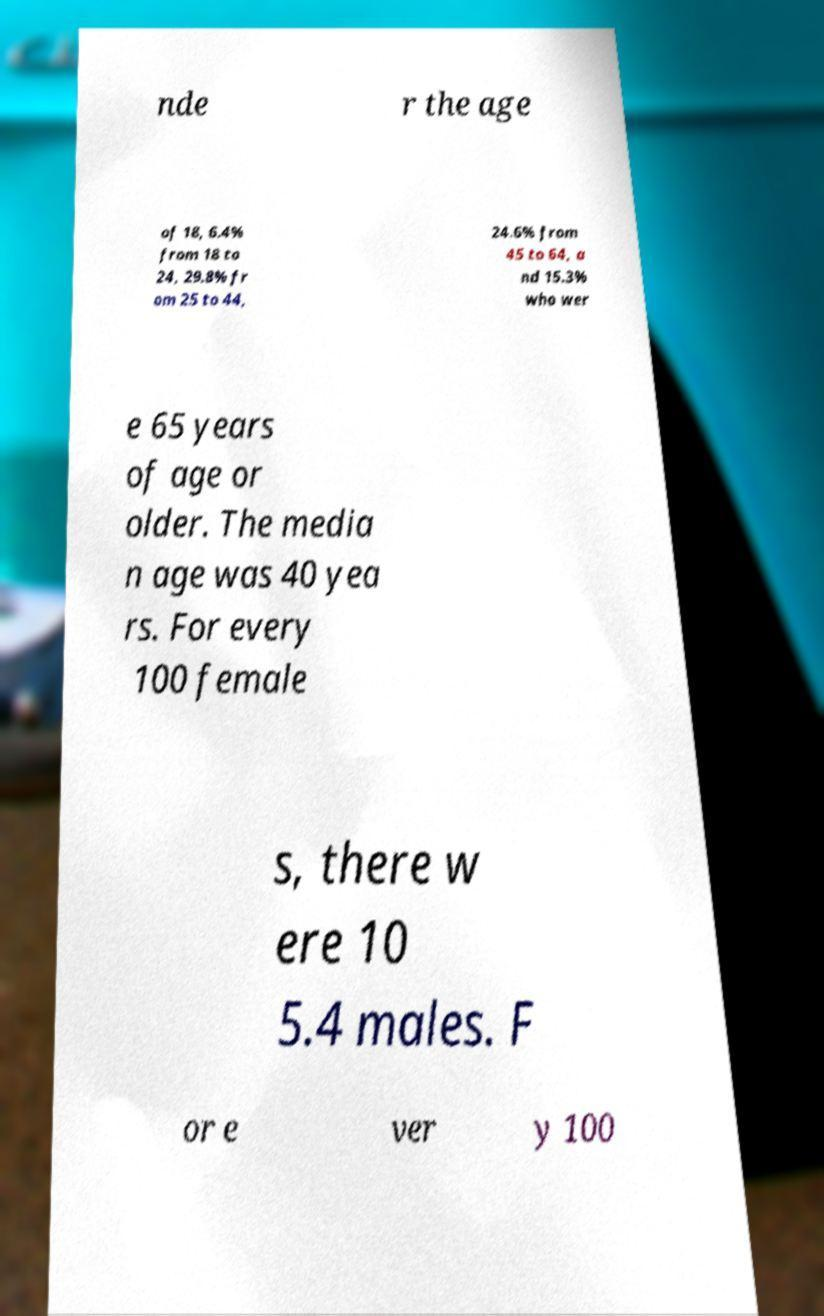Could you extract and type out the text from this image? nde r the age of 18, 6.4% from 18 to 24, 29.8% fr om 25 to 44, 24.6% from 45 to 64, a nd 15.3% who wer e 65 years of age or older. The media n age was 40 yea rs. For every 100 female s, there w ere 10 5.4 males. F or e ver y 100 